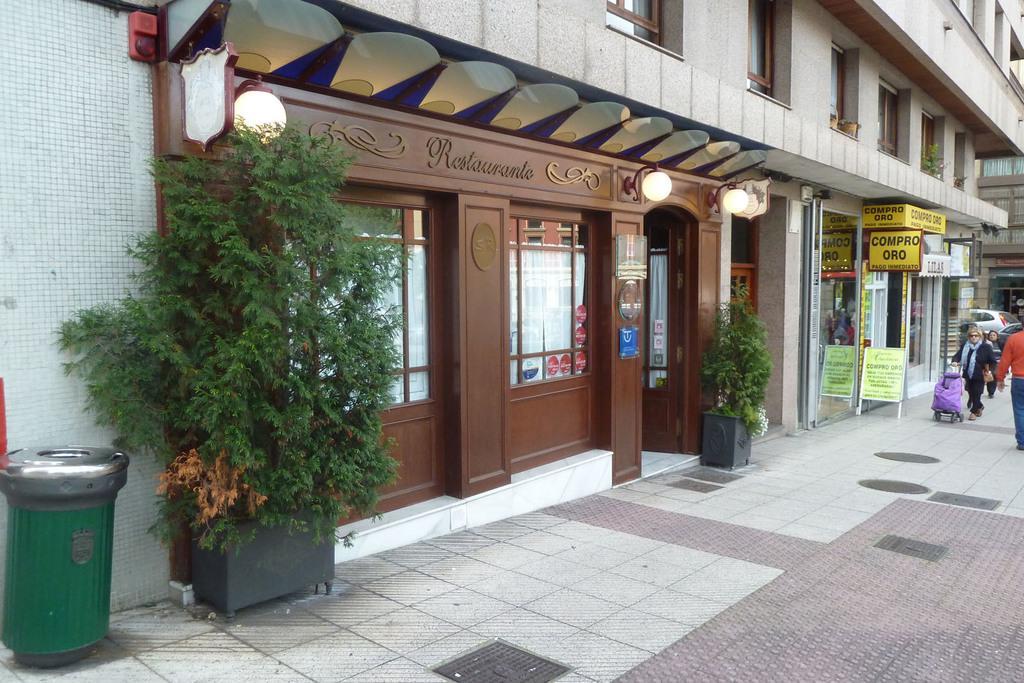Could you give a brief overview of what you see in this image? At the left side of the picture we can see buildings. These are plants with pots. This is a trash can in green color. At the right side of the picture we can see people walking. These are lights. 